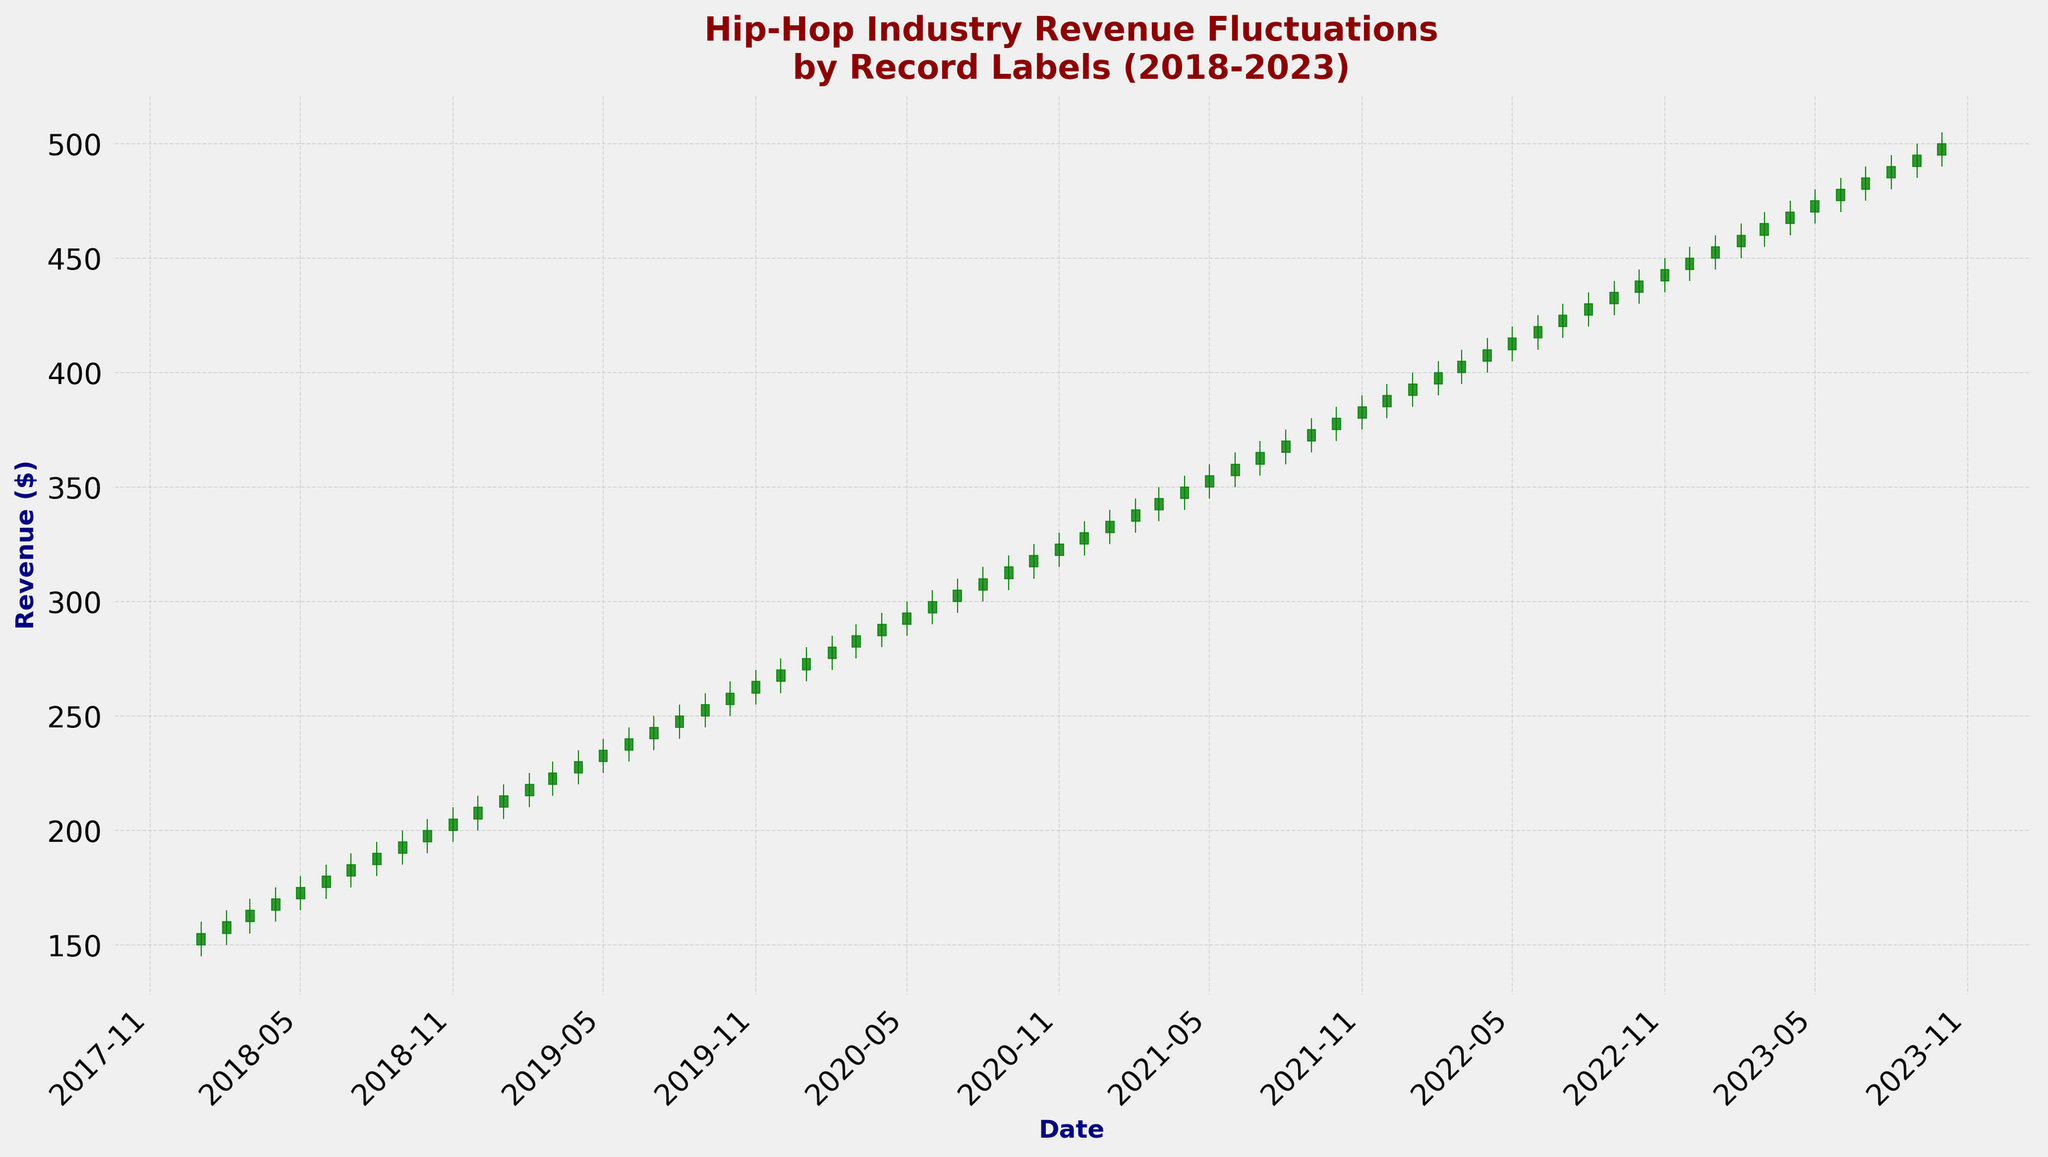Which month had the highest opening revenue and what was the value? To find the highest opening revenue month, locate the highest value in the Open column on the x-axis labeled with dates. The highest opening revenue is in October 2023 with a value of 495.
Answer: October 2023, 495 How many months saw a decline in the closing revenue from the previous month? To identify this, compare the closing revenue of each month with the previous month. Each downward trend or "red" candlestick represents a decline. Based on the chart from 2018 to 2023, there are no visible declines since all candlesticks are green.
Answer: 0 What is the average closing revenue for the year 2018? Calculate the average of the closing revenue for the months of 2018. Sum the closing values and divide by 12. The closing values are 155, 160, 165, 170, 175, 180, 185, 190, 195, 200, 205, and 210. The sum is 2200, and the average is 2200/12 = 183.33.
Answer: 183.33 How does the closing revenue in July 2021 compare to the closing revenue in December 2020? To compare, find the closing values for July 2021 and December 2020. July 2021 closed at 365, and December 2020 closed at 330. Compare the two values to see that July 2021 is greater.
Answer: July 2021 > December 2020 By how much did the closing revenue increase from July 2018 to July 2019? Find the closing revenue for both months. July 2018 closed at 185, and July 2019 closed at 245. Subtract the former from the latter (245 - 185). Therefore, the increase is 60.
Answer: 60 Which months in 2022 have the same closing and opening revenue? Identify the months where the opening and closing prices are equal by looking for candlesticks with no visible body and whose opening and closing values on the vertical axis are the same. No such candlesticks are observed in 2022.
Answer: None What's the trend in revenue (increase or decrease) between January 2020 and January 2021? Compare the closing revenue at the beginning and end of this period. January 2020 closed at 275, and January 2021 closed at 335. Since 335 is greater than 275, there's an increasing trend.
Answer: Increase What's the difference between the highest and the lowest closing revenue observed over the entire period? Find the highest closing value (500 in October 2023) and the lowest (155 in January 2018), then calculate the difference (500 - 155). The difference amounts to 345.
Answer: 345 